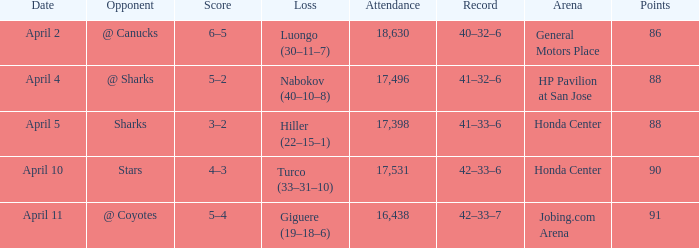What score has a loss of hiller (22-15-1)? 3–2. 